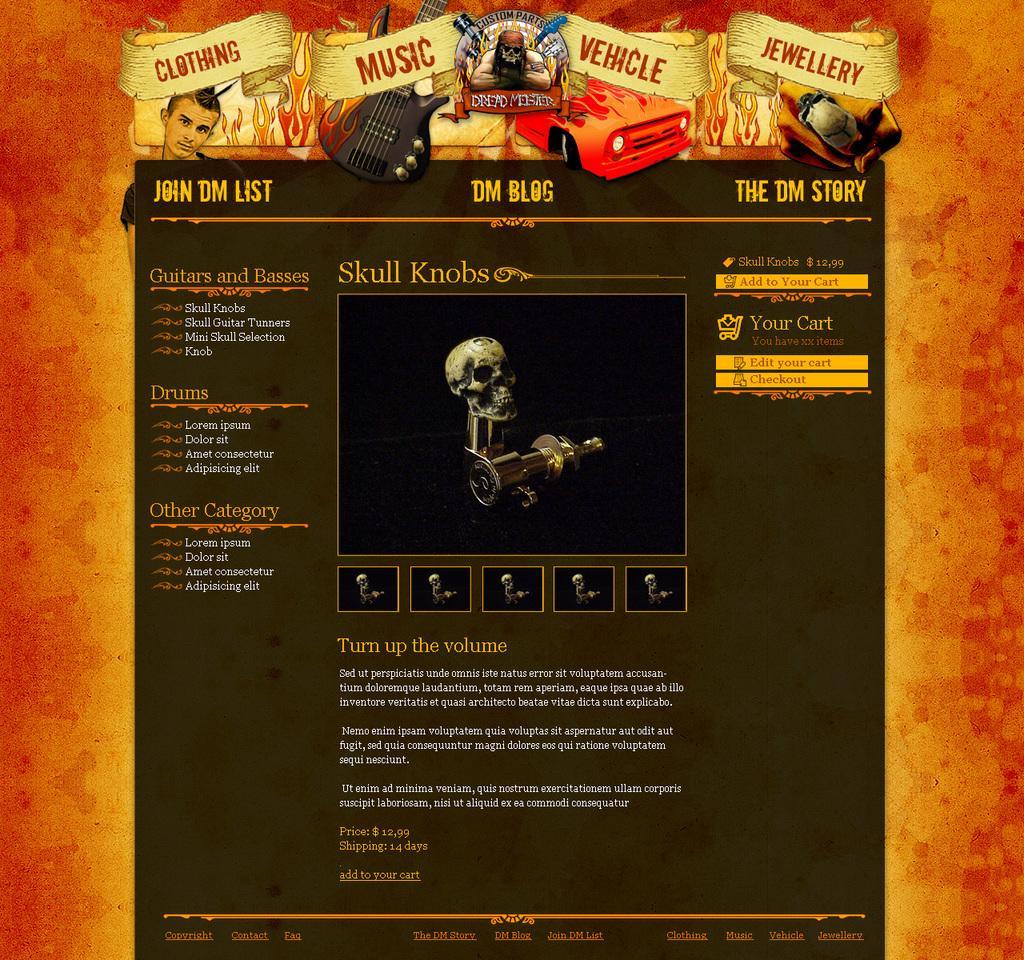In one or two sentences, can you explain what this image depicts? In this picture we can see the poster. In this poster we can see a skeleton and a person. At the bottom we can see the articles. 